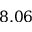<formula> <loc_0><loc_0><loc_500><loc_500>8 . 0 6</formula> 